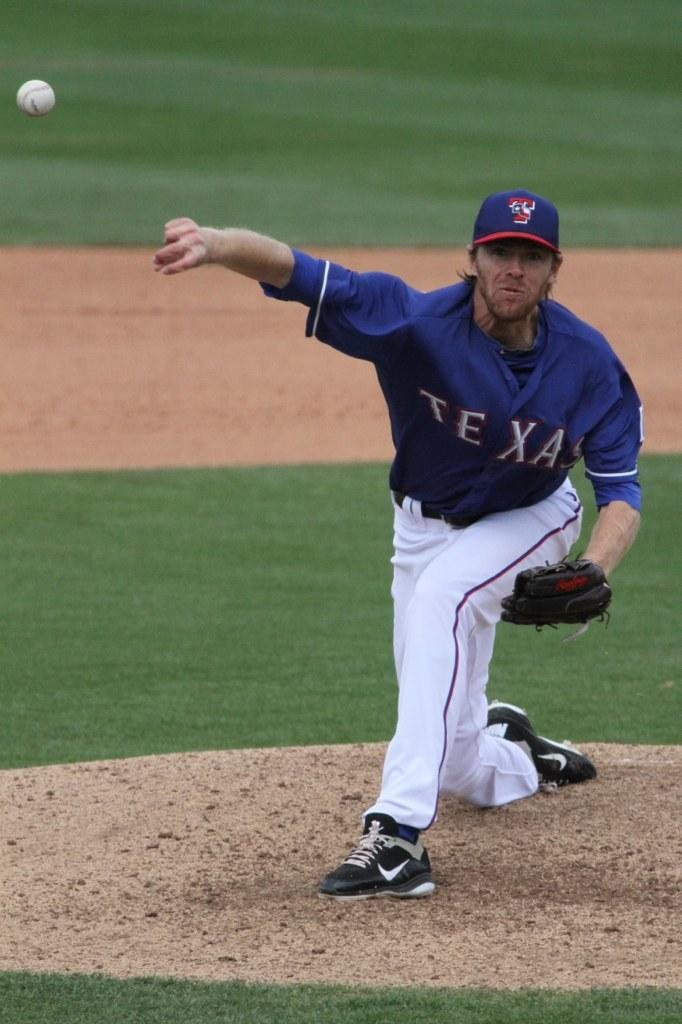<image>
Summarize the visual content of the image. a man in a Texas baseball uniform is throwing a baseball 